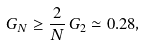<formula> <loc_0><loc_0><loc_500><loc_500>G _ { N } \geq \frac { 2 } { N } \, G _ { 2 } \simeq 0 . 2 8 ,</formula> 